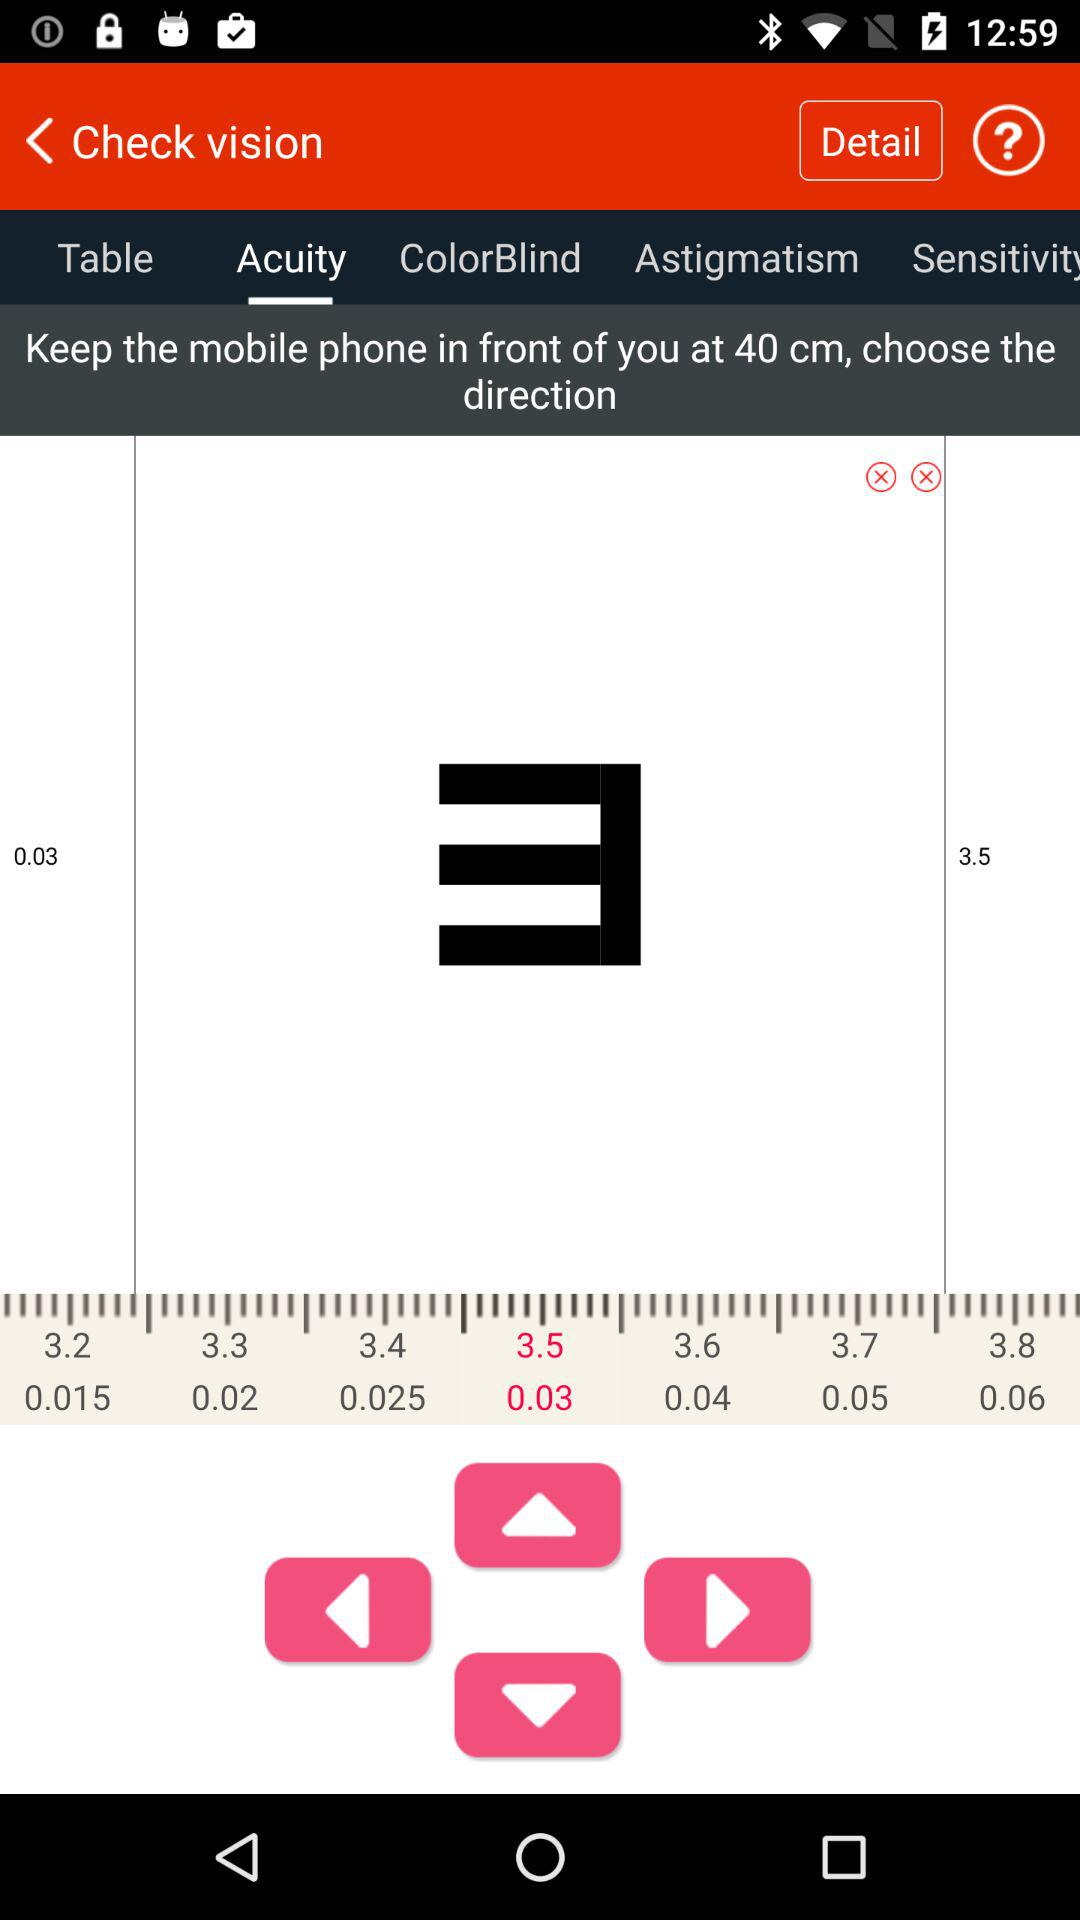At what distance, in cm, should the phone be kept? The phone should be kept at a distance of 40 cm. 